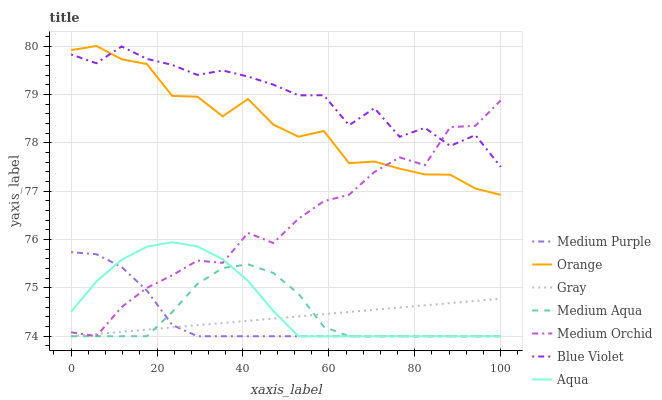Does Medium Orchid have the minimum area under the curve?
Answer yes or no. No. Does Medium Orchid have the maximum area under the curve?
Answer yes or no. No. Is Medium Orchid the smoothest?
Answer yes or no. No. Is Medium Orchid the roughest?
Answer yes or no. No. Does Orange have the lowest value?
Answer yes or no. No. Does Medium Orchid have the highest value?
Answer yes or no. No. Is Aqua less than Blue Violet?
Answer yes or no. Yes. Is Blue Violet greater than Gray?
Answer yes or no. Yes. Does Aqua intersect Blue Violet?
Answer yes or no. No. 